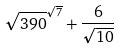<formula> <loc_0><loc_0><loc_500><loc_500>\sqrt { 3 9 0 } ^ { \sqrt { 7 } } + \frac { 6 } { \sqrt { 1 0 } }</formula> 